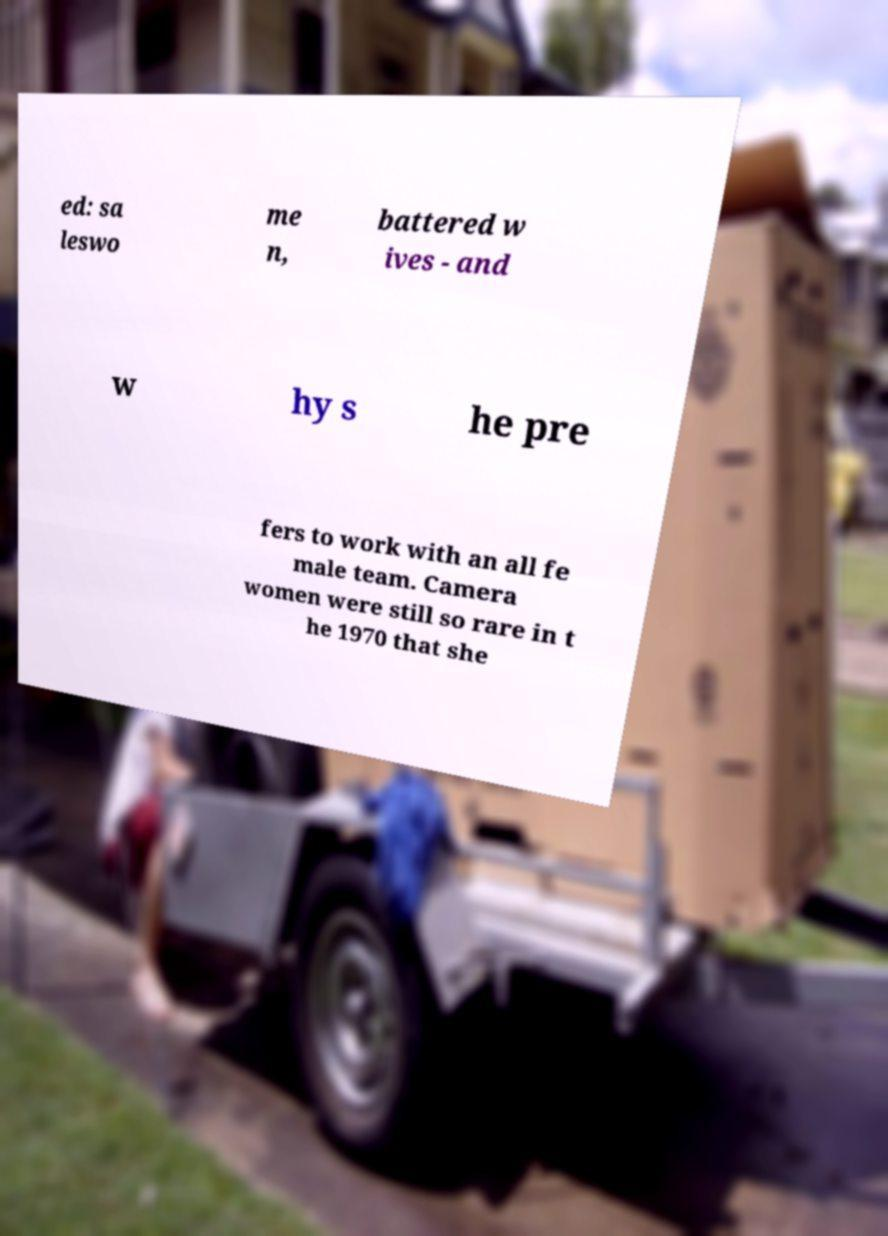Could you assist in decoding the text presented in this image and type it out clearly? ed: sa leswo me n, battered w ives - and w hy s he pre fers to work with an all fe male team. Camera women were still so rare in t he 1970 that she 